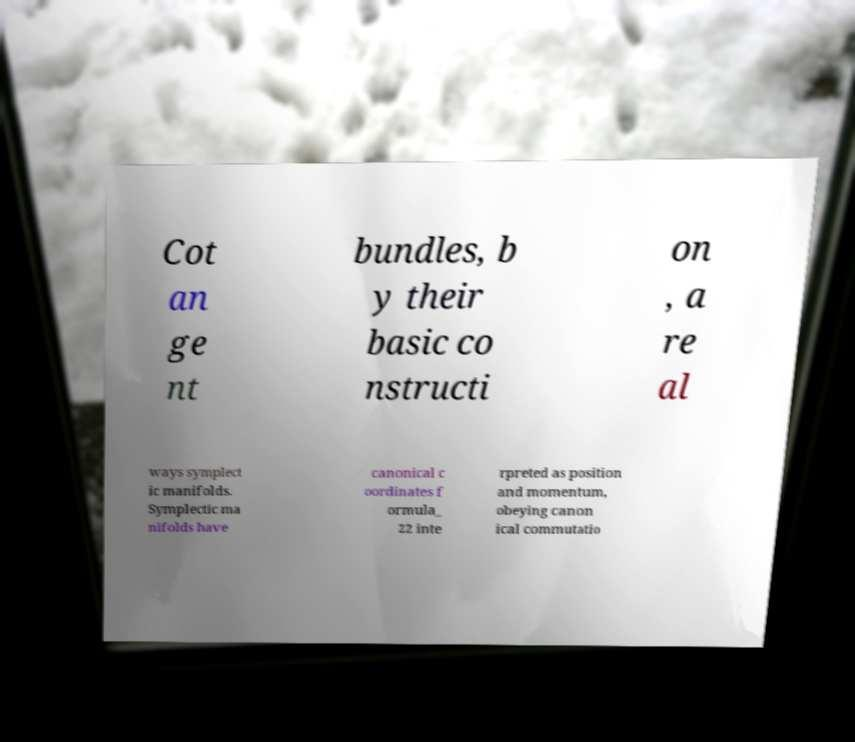Please identify and transcribe the text found in this image. Cot an ge nt bundles, b y their basic co nstructi on , a re al ways symplect ic manifolds. Symplectic ma nifolds have canonical c oordinates f ormula_ 22 inte rpreted as position and momentum, obeying canon ical commutatio 